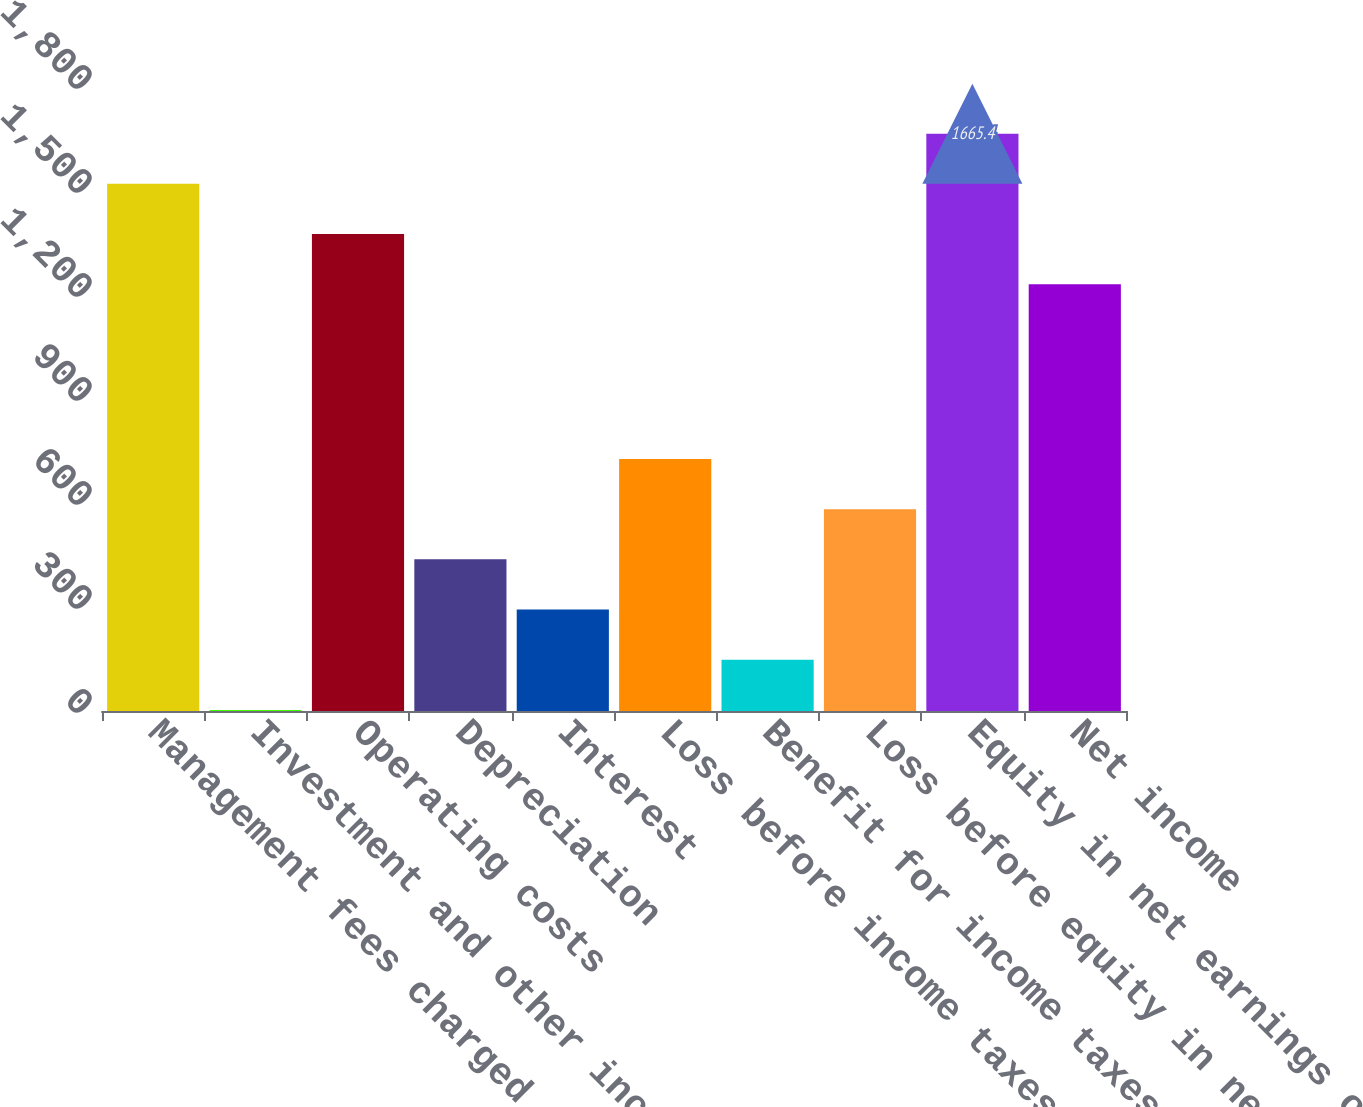Convert chart. <chart><loc_0><loc_0><loc_500><loc_500><bar_chart><fcel>Management fees charged to<fcel>Investment and other income<fcel>Operating costs<fcel>Depreciation<fcel>Interest<fcel>Loss before income taxes and<fcel>Benefit for income taxes<fcel>Loss before equity in net<fcel>Equity in net earnings of<fcel>Net income<nl><fcel>1520.6<fcel>3<fcel>1375.8<fcel>437.4<fcel>292.6<fcel>727<fcel>147.8<fcel>582.2<fcel>1665.4<fcel>1231<nl></chart> 